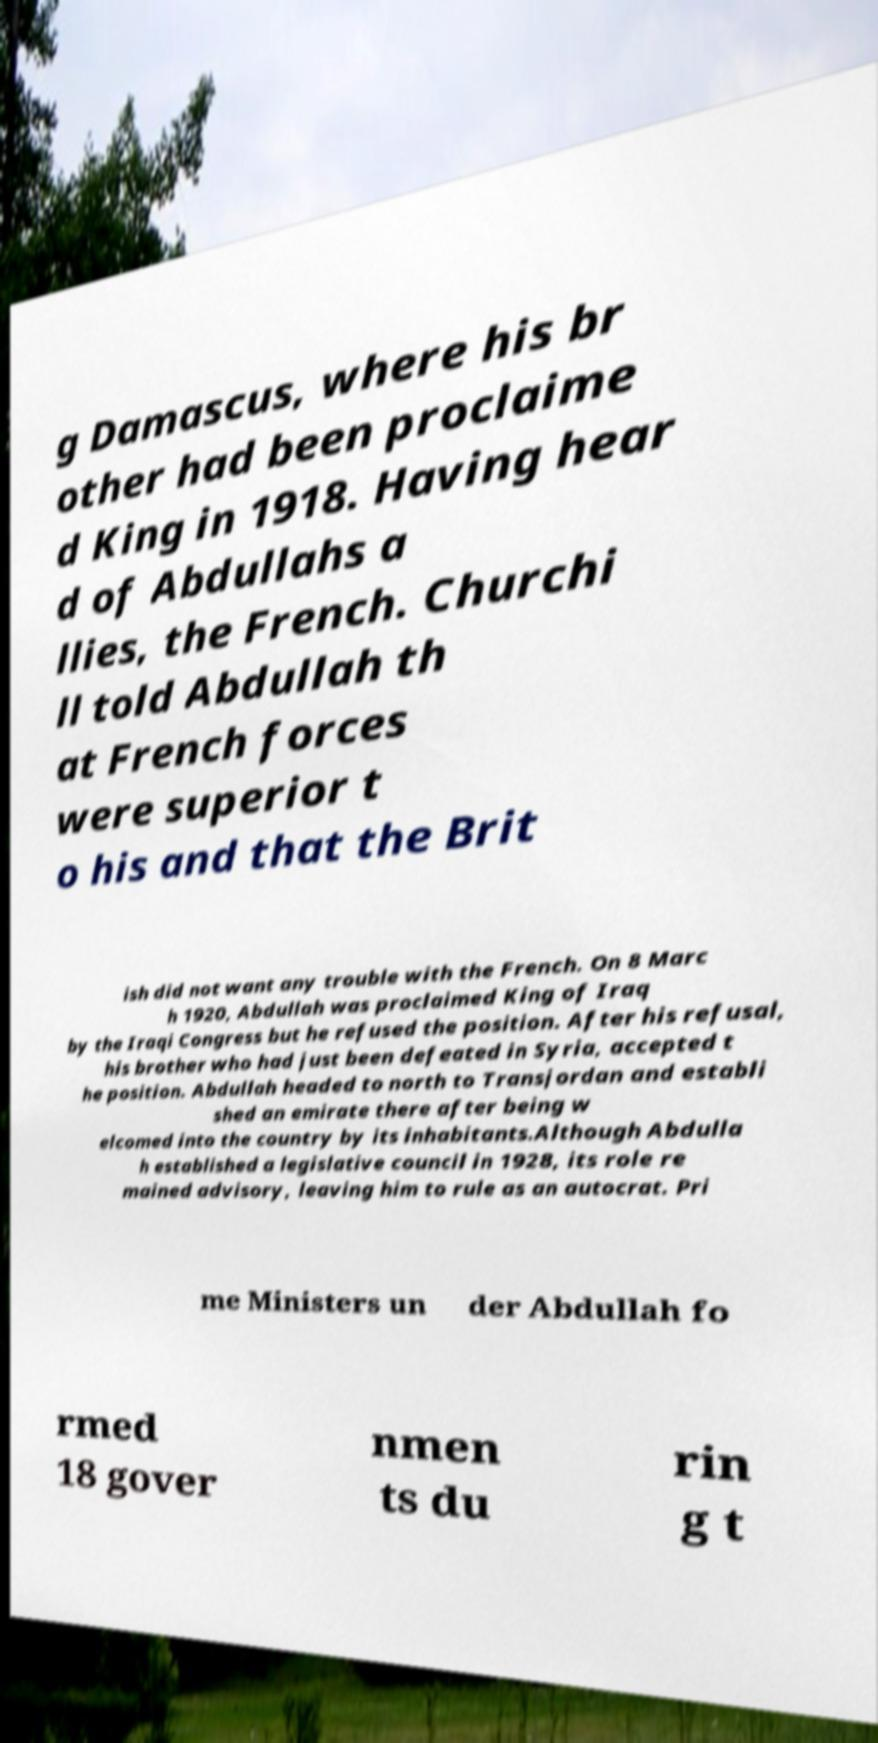Can you read and provide the text displayed in the image?This photo seems to have some interesting text. Can you extract and type it out for me? g Damascus, where his br other had been proclaime d King in 1918. Having hear d of Abdullahs a llies, the French. Churchi ll told Abdullah th at French forces were superior t o his and that the Brit ish did not want any trouble with the French. On 8 Marc h 1920, Abdullah was proclaimed King of Iraq by the Iraqi Congress but he refused the position. After his refusal, his brother who had just been defeated in Syria, accepted t he position. Abdullah headed to north to Transjordan and establi shed an emirate there after being w elcomed into the country by its inhabitants.Although Abdulla h established a legislative council in 1928, its role re mained advisory, leaving him to rule as an autocrat. Pri me Ministers un der Abdullah fo rmed 18 gover nmen ts du rin g t 